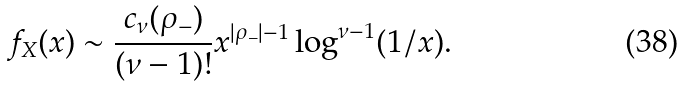Convert formula to latex. <formula><loc_0><loc_0><loc_500><loc_500>f _ { X } ( x ) \sim \frac { c _ { \nu } ( \rho _ { - } ) } { ( \nu - 1 ) ! } x ^ { | \rho _ { - } | - 1 } \log ^ { \nu - 1 } ( 1 / x ) .</formula> 